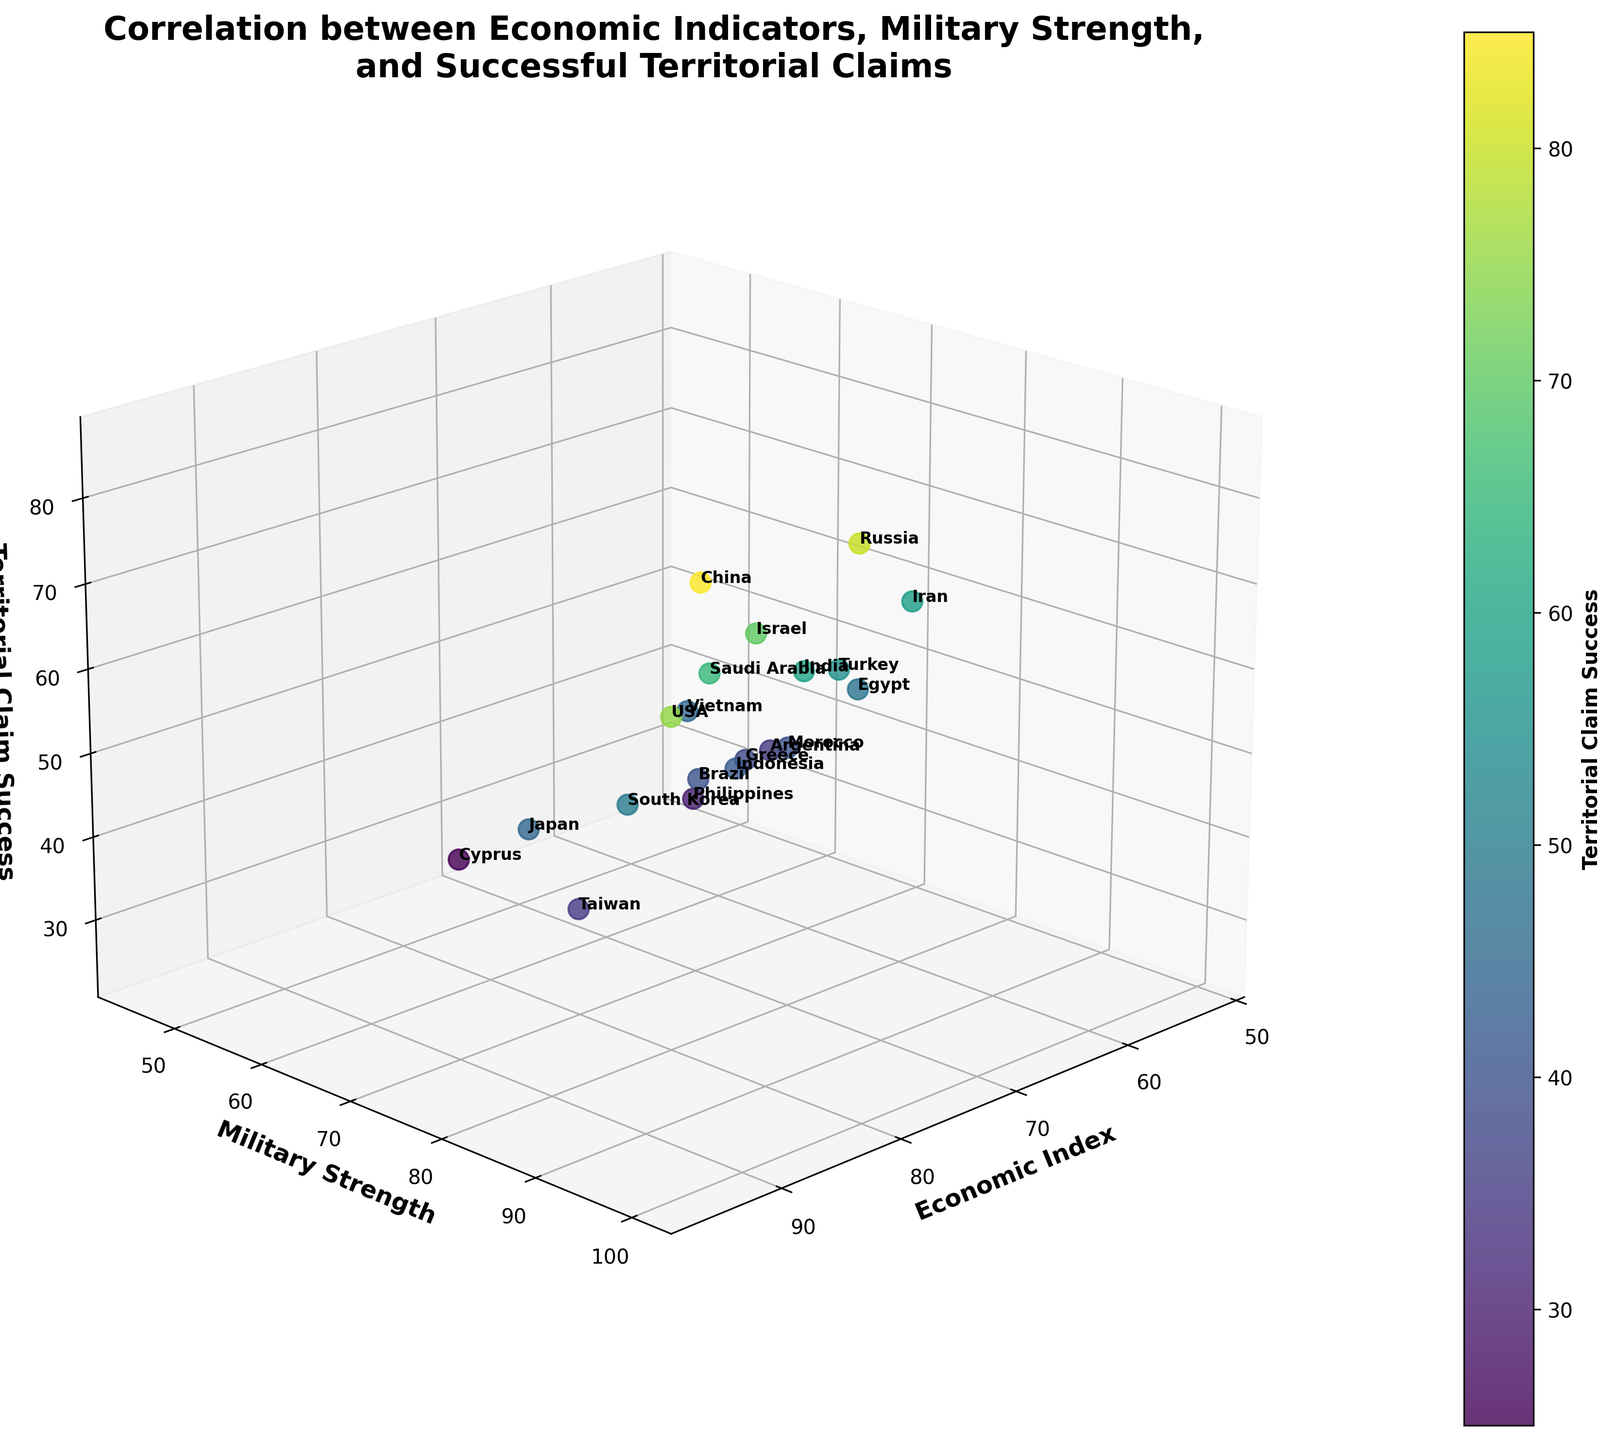What is the title of the plot? The title of the plot is written at the top of the figure in a bold and slightly larger font. It is a descriptive phrase that gives an overview of the figure's content.
Answer: Correlation between Economic Indicators, Military Strength, and Successful Territorial Claims How many countries are represented in the plot? The number of countries can be inferred by counting the distinct data points or the labels next to those data points in the figure. Each label represents a different country.
Answer: 20 Which country has the highest Economic Index and what is its Territorial Claim Success? By examining the plot, locate the data point with the highest value on the Economic Index axis, and check its corresponding value on the Territorial Claim Success axis. The country's label will identify it.
Answer: USA, 75 How does the Military Strength of Japan compare to that of Brazil? Locate both Japan and Brazil on the plot, then compare their positions along the Military Strength axis to ascertain which is more significant.
Answer: Japan has a higher Military Strength than Brazil What is the average Military Strength of China, Russia, and the USA? Identify the Military Strength values of China, Russia, and the USA from their plotted positions, sum these values, and divide by the number of countries to get the average.
Answer: (95 + 90 + 100) / 3 = 95 Which country with a Territorial Claim Success of above 50 has the lowest Economic Index? Filter the plot to focus on countries with a Territorial Claim Success above 50, and then within this subset, locate the country with the lowest value on the Economic Index axis.
Answer: Iran What is the difference in Territorial Claim Success between Israel and Taiwan? Locate Israel and Taiwan on the plot, then subtract Taiwan's Territorial Claim Success value from Israel's.
Answer: 70 - 35 = 35 Which countries fall below an Economic Index of 60 but have a Military Strength above 60? Identify countries with values below 60 on the Economic Index axis and above 60 on the Military Strength axis.
Answer: Egypt, Iran, Greece What range of values does the color bar represent in terms of Territorial Claim Success? The color bar beside the plot represents the range of Territorial Claim Success values. Read its starting and ending values.
Answer: 25 to 85 Explain the 3D positioning of the data points for China, Japan, and Saudi Arabia. Describe the positions of China, Japan, and Saudi Arabia by mentioning their values on the Economic Index, Military Strength, and Territorial Claim Success axes, and compare their coordinates in the 3D space.
Answer: China: (89.5, 95, 85), Japan: (84.2, 70, 45), Saudi Arabia: (78.4, 82, 65) 